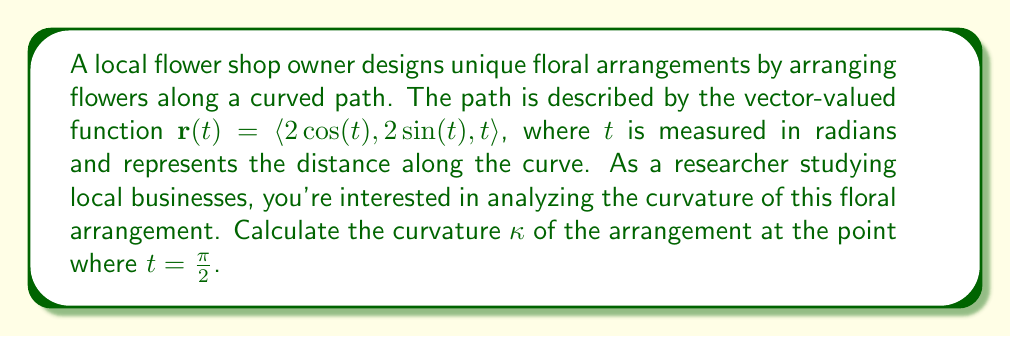Provide a solution to this math problem. To find the curvature of the floral arrangement, we'll use the formula for curvature of a vector-valued function:

$$\kappa = \frac{|\mathbf{r}'(t) \times \mathbf{r}''(t)|}{|\mathbf{r}'(t)|^3}$$

Let's follow these steps:

1) First, we need to find $\mathbf{r}'(t)$ and $\mathbf{r}''(t)$:

   $\mathbf{r}'(t) = \langle -2\sin(t), 2\cos(t), 1 \rangle$
   $\mathbf{r}''(t) = \langle -2\cos(t), -2\sin(t), 0 \rangle$

2) Now, let's calculate $\mathbf{r}'(t) \times \mathbf{r}''(t)$:

   $$\begin{vmatrix} 
   \mathbf{i} & \mathbf{j} & \mathbf{k} \\
   -2\sin(t) & 2\cos(t) & 1 \\
   -2\cos(t) & -2\sin(t) & 0
   \end{vmatrix}$$

   $= \langle -2\sin(t), -2\cos(t), -4 \rangle$

3) The magnitude of this cross product is:

   $|\mathbf{r}'(t) \times \mathbf{r}''(t)| = \sqrt{4\sin^2(t) + 4\cos^2(t) + 16} = \sqrt{4 + 16} = \sqrt{20} = 2\sqrt{5}$

4) Next, we need to calculate $|\mathbf{r}'(t)|^3$:

   $|\mathbf{r}'(t)| = \sqrt{4\sin^2(t) + 4\cos^2(t) + 1} = \sqrt{4 + 1} = \sqrt{5}$

   $|\mathbf{r}'(t)|^3 = (\sqrt{5})^3 = 5\sqrt{5}$

5) Now we can plug these values into our curvature formula:

   $$\kappa = \frac{2\sqrt{5}}{5\sqrt{5}} = \frac{2}{5}$$

6) This result is constant for all $t$, including $t = \frac{\pi}{2}$.
Answer: The curvature of the floral arrangement at $t = \frac{\pi}{2}$ is $\kappa = \frac{2}{5}$. 